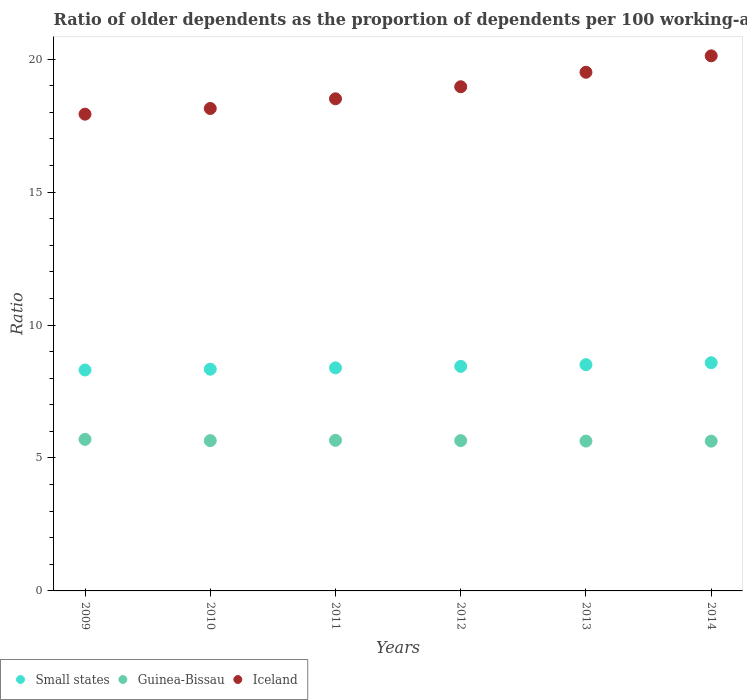How many different coloured dotlines are there?
Make the answer very short. 3. Is the number of dotlines equal to the number of legend labels?
Ensure brevity in your answer.  Yes. What is the age dependency ratio(old) in Guinea-Bissau in 2011?
Provide a short and direct response. 5.66. Across all years, what is the maximum age dependency ratio(old) in Small states?
Provide a short and direct response. 8.58. Across all years, what is the minimum age dependency ratio(old) in Guinea-Bissau?
Your answer should be compact. 5.63. In which year was the age dependency ratio(old) in Small states maximum?
Offer a very short reply. 2014. In which year was the age dependency ratio(old) in Iceland minimum?
Your answer should be very brief. 2009. What is the total age dependency ratio(old) in Guinea-Bissau in the graph?
Ensure brevity in your answer.  33.94. What is the difference between the age dependency ratio(old) in Guinea-Bissau in 2011 and that in 2013?
Your answer should be very brief. 0.03. What is the difference between the age dependency ratio(old) in Iceland in 2011 and the age dependency ratio(old) in Guinea-Bissau in 2009?
Offer a very short reply. 12.81. What is the average age dependency ratio(old) in Small states per year?
Your response must be concise. 8.43. In the year 2013, what is the difference between the age dependency ratio(old) in Guinea-Bissau and age dependency ratio(old) in Iceland?
Offer a very short reply. -13.87. What is the ratio of the age dependency ratio(old) in Guinea-Bissau in 2009 to that in 2013?
Your answer should be compact. 1.01. What is the difference between the highest and the second highest age dependency ratio(old) in Iceland?
Offer a very short reply. 0.62. What is the difference between the highest and the lowest age dependency ratio(old) in Small states?
Provide a succinct answer. 0.27. In how many years, is the age dependency ratio(old) in Guinea-Bissau greater than the average age dependency ratio(old) in Guinea-Bissau taken over all years?
Offer a terse response. 2. Is the sum of the age dependency ratio(old) in Small states in 2011 and 2013 greater than the maximum age dependency ratio(old) in Iceland across all years?
Make the answer very short. No. Is the age dependency ratio(old) in Guinea-Bissau strictly greater than the age dependency ratio(old) in Iceland over the years?
Offer a terse response. No. How many dotlines are there?
Your response must be concise. 3. How many years are there in the graph?
Offer a very short reply. 6. What is the difference between two consecutive major ticks on the Y-axis?
Keep it short and to the point. 5. Are the values on the major ticks of Y-axis written in scientific E-notation?
Keep it short and to the point. No. Does the graph contain any zero values?
Your response must be concise. No. How many legend labels are there?
Your answer should be compact. 3. What is the title of the graph?
Ensure brevity in your answer.  Ratio of older dependents as the proportion of dependents per 100 working-age population. Does "Iceland" appear as one of the legend labels in the graph?
Provide a short and direct response. Yes. What is the label or title of the X-axis?
Give a very brief answer. Years. What is the label or title of the Y-axis?
Offer a very short reply. Ratio. What is the Ratio of Small states in 2009?
Keep it short and to the point. 8.31. What is the Ratio of Guinea-Bissau in 2009?
Offer a very short reply. 5.7. What is the Ratio in Iceland in 2009?
Provide a short and direct response. 17.93. What is the Ratio of Small states in 2010?
Provide a succinct answer. 8.34. What is the Ratio of Guinea-Bissau in 2010?
Offer a terse response. 5.65. What is the Ratio in Iceland in 2010?
Your answer should be very brief. 18.15. What is the Ratio in Small states in 2011?
Your answer should be very brief. 8.39. What is the Ratio of Guinea-Bissau in 2011?
Keep it short and to the point. 5.66. What is the Ratio of Iceland in 2011?
Your response must be concise. 18.51. What is the Ratio in Small states in 2012?
Make the answer very short. 8.45. What is the Ratio of Guinea-Bissau in 2012?
Ensure brevity in your answer.  5.65. What is the Ratio in Iceland in 2012?
Offer a terse response. 18.96. What is the Ratio of Small states in 2013?
Provide a succinct answer. 8.51. What is the Ratio in Guinea-Bissau in 2013?
Provide a succinct answer. 5.64. What is the Ratio of Iceland in 2013?
Ensure brevity in your answer.  19.51. What is the Ratio of Small states in 2014?
Provide a short and direct response. 8.58. What is the Ratio of Guinea-Bissau in 2014?
Provide a short and direct response. 5.63. What is the Ratio in Iceland in 2014?
Provide a short and direct response. 20.13. Across all years, what is the maximum Ratio in Small states?
Make the answer very short. 8.58. Across all years, what is the maximum Ratio in Guinea-Bissau?
Provide a succinct answer. 5.7. Across all years, what is the maximum Ratio of Iceland?
Make the answer very short. 20.13. Across all years, what is the minimum Ratio in Small states?
Make the answer very short. 8.31. Across all years, what is the minimum Ratio of Guinea-Bissau?
Give a very brief answer. 5.63. Across all years, what is the minimum Ratio of Iceland?
Keep it short and to the point. 17.93. What is the total Ratio of Small states in the graph?
Make the answer very short. 50.58. What is the total Ratio in Guinea-Bissau in the graph?
Offer a very short reply. 33.94. What is the total Ratio in Iceland in the graph?
Offer a very short reply. 113.19. What is the difference between the Ratio of Small states in 2009 and that in 2010?
Your response must be concise. -0.03. What is the difference between the Ratio in Guinea-Bissau in 2009 and that in 2010?
Make the answer very short. 0.05. What is the difference between the Ratio of Iceland in 2009 and that in 2010?
Your answer should be very brief. -0.21. What is the difference between the Ratio of Small states in 2009 and that in 2011?
Provide a short and direct response. -0.08. What is the difference between the Ratio in Guinea-Bissau in 2009 and that in 2011?
Your answer should be compact. 0.04. What is the difference between the Ratio in Iceland in 2009 and that in 2011?
Offer a terse response. -0.58. What is the difference between the Ratio of Small states in 2009 and that in 2012?
Your answer should be compact. -0.14. What is the difference between the Ratio of Guinea-Bissau in 2009 and that in 2012?
Provide a succinct answer. 0.05. What is the difference between the Ratio in Iceland in 2009 and that in 2012?
Keep it short and to the point. -1.03. What is the difference between the Ratio of Small states in 2009 and that in 2013?
Offer a very short reply. -0.2. What is the difference between the Ratio in Guinea-Bissau in 2009 and that in 2013?
Keep it short and to the point. 0.06. What is the difference between the Ratio of Iceland in 2009 and that in 2013?
Offer a terse response. -1.58. What is the difference between the Ratio of Small states in 2009 and that in 2014?
Provide a succinct answer. -0.27. What is the difference between the Ratio in Guinea-Bissau in 2009 and that in 2014?
Your answer should be compact. 0.07. What is the difference between the Ratio in Iceland in 2009 and that in 2014?
Ensure brevity in your answer.  -2.19. What is the difference between the Ratio of Small states in 2010 and that in 2011?
Give a very brief answer. -0.05. What is the difference between the Ratio of Guinea-Bissau in 2010 and that in 2011?
Provide a succinct answer. -0.01. What is the difference between the Ratio in Iceland in 2010 and that in 2011?
Provide a succinct answer. -0.36. What is the difference between the Ratio in Small states in 2010 and that in 2012?
Your response must be concise. -0.11. What is the difference between the Ratio of Guinea-Bissau in 2010 and that in 2012?
Keep it short and to the point. -0. What is the difference between the Ratio in Iceland in 2010 and that in 2012?
Give a very brief answer. -0.82. What is the difference between the Ratio of Small states in 2010 and that in 2013?
Ensure brevity in your answer.  -0.17. What is the difference between the Ratio of Guinea-Bissau in 2010 and that in 2013?
Offer a terse response. 0.02. What is the difference between the Ratio of Iceland in 2010 and that in 2013?
Your answer should be very brief. -1.36. What is the difference between the Ratio of Small states in 2010 and that in 2014?
Provide a succinct answer. -0.24. What is the difference between the Ratio in Guinea-Bissau in 2010 and that in 2014?
Offer a very short reply. 0.02. What is the difference between the Ratio of Iceland in 2010 and that in 2014?
Offer a very short reply. -1.98. What is the difference between the Ratio in Small states in 2011 and that in 2012?
Keep it short and to the point. -0.06. What is the difference between the Ratio of Guinea-Bissau in 2011 and that in 2012?
Your answer should be compact. 0.01. What is the difference between the Ratio of Iceland in 2011 and that in 2012?
Make the answer very short. -0.45. What is the difference between the Ratio of Small states in 2011 and that in 2013?
Offer a very short reply. -0.12. What is the difference between the Ratio in Guinea-Bissau in 2011 and that in 2013?
Keep it short and to the point. 0.03. What is the difference between the Ratio in Iceland in 2011 and that in 2013?
Give a very brief answer. -1. What is the difference between the Ratio in Small states in 2011 and that in 2014?
Ensure brevity in your answer.  -0.19. What is the difference between the Ratio of Guinea-Bissau in 2011 and that in 2014?
Make the answer very short. 0.03. What is the difference between the Ratio of Iceland in 2011 and that in 2014?
Make the answer very short. -1.62. What is the difference between the Ratio of Small states in 2012 and that in 2013?
Provide a succinct answer. -0.06. What is the difference between the Ratio in Guinea-Bissau in 2012 and that in 2013?
Your answer should be very brief. 0.02. What is the difference between the Ratio of Iceland in 2012 and that in 2013?
Keep it short and to the point. -0.55. What is the difference between the Ratio in Small states in 2012 and that in 2014?
Give a very brief answer. -0.14. What is the difference between the Ratio in Guinea-Bissau in 2012 and that in 2014?
Give a very brief answer. 0.02. What is the difference between the Ratio in Iceland in 2012 and that in 2014?
Make the answer very short. -1.16. What is the difference between the Ratio of Small states in 2013 and that in 2014?
Give a very brief answer. -0.07. What is the difference between the Ratio of Guinea-Bissau in 2013 and that in 2014?
Your answer should be very brief. 0. What is the difference between the Ratio in Iceland in 2013 and that in 2014?
Give a very brief answer. -0.62. What is the difference between the Ratio in Small states in 2009 and the Ratio in Guinea-Bissau in 2010?
Your answer should be very brief. 2.66. What is the difference between the Ratio of Small states in 2009 and the Ratio of Iceland in 2010?
Ensure brevity in your answer.  -9.84. What is the difference between the Ratio in Guinea-Bissau in 2009 and the Ratio in Iceland in 2010?
Provide a succinct answer. -12.45. What is the difference between the Ratio of Small states in 2009 and the Ratio of Guinea-Bissau in 2011?
Give a very brief answer. 2.64. What is the difference between the Ratio in Small states in 2009 and the Ratio in Iceland in 2011?
Your answer should be compact. -10.2. What is the difference between the Ratio of Guinea-Bissau in 2009 and the Ratio of Iceland in 2011?
Provide a succinct answer. -12.81. What is the difference between the Ratio in Small states in 2009 and the Ratio in Guinea-Bissau in 2012?
Ensure brevity in your answer.  2.66. What is the difference between the Ratio in Small states in 2009 and the Ratio in Iceland in 2012?
Offer a terse response. -10.65. What is the difference between the Ratio of Guinea-Bissau in 2009 and the Ratio of Iceland in 2012?
Keep it short and to the point. -13.26. What is the difference between the Ratio in Small states in 2009 and the Ratio in Guinea-Bissau in 2013?
Make the answer very short. 2.67. What is the difference between the Ratio in Small states in 2009 and the Ratio in Iceland in 2013?
Make the answer very short. -11.2. What is the difference between the Ratio in Guinea-Bissau in 2009 and the Ratio in Iceland in 2013?
Offer a terse response. -13.81. What is the difference between the Ratio in Small states in 2009 and the Ratio in Guinea-Bissau in 2014?
Provide a succinct answer. 2.68. What is the difference between the Ratio of Small states in 2009 and the Ratio of Iceland in 2014?
Provide a succinct answer. -11.82. What is the difference between the Ratio in Guinea-Bissau in 2009 and the Ratio in Iceland in 2014?
Keep it short and to the point. -14.43. What is the difference between the Ratio in Small states in 2010 and the Ratio in Guinea-Bissau in 2011?
Your response must be concise. 2.68. What is the difference between the Ratio of Small states in 2010 and the Ratio of Iceland in 2011?
Provide a short and direct response. -10.17. What is the difference between the Ratio in Guinea-Bissau in 2010 and the Ratio in Iceland in 2011?
Offer a very short reply. -12.86. What is the difference between the Ratio of Small states in 2010 and the Ratio of Guinea-Bissau in 2012?
Give a very brief answer. 2.69. What is the difference between the Ratio in Small states in 2010 and the Ratio in Iceland in 2012?
Your answer should be compact. -10.62. What is the difference between the Ratio of Guinea-Bissau in 2010 and the Ratio of Iceland in 2012?
Offer a very short reply. -13.31. What is the difference between the Ratio in Small states in 2010 and the Ratio in Guinea-Bissau in 2013?
Keep it short and to the point. 2.7. What is the difference between the Ratio of Small states in 2010 and the Ratio of Iceland in 2013?
Keep it short and to the point. -11.17. What is the difference between the Ratio of Guinea-Bissau in 2010 and the Ratio of Iceland in 2013?
Offer a very short reply. -13.86. What is the difference between the Ratio in Small states in 2010 and the Ratio in Guinea-Bissau in 2014?
Offer a very short reply. 2.71. What is the difference between the Ratio of Small states in 2010 and the Ratio of Iceland in 2014?
Offer a very short reply. -11.79. What is the difference between the Ratio of Guinea-Bissau in 2010 and the Ratio of Iceland in 2014?
Offer a very short reply. -14.47. What is the difference between the Ratio in Small states in 2011 and the Ratio in Guinea-Bissau in 2012?
Ensure brevity in your answer.  2.74. What is the difference between the Ratio of Small states in 2011 and the Ratio of Iceland in 2012?
Offer a very short reply. -10.57. What is the difference between the Ratio in Guinea-Bissau in 2011 and the Ratio in Iceland in 2012?
Ensure brevity in your answer.  -13.3. What is the difference between the Ratio in Small states in 2011 and the Ratio in Guinea-Bissau in 2013?
Keep it short and to the point. 2.75. What is the difference between the Ratio in Small states in 2011 and the Ratio in Iceland in 2013?
Give a very brief answer. -11.12. What is the difference between the Ratio of Guinea-Bissau in 2011 and the Ratio of Iceland in 2013?
Provide a short and direct response. -13.84. What is the difference between the Ratio in Small states in 2011 and the Ratio in Guinea-Bissau in 2014?
Your answer should be very brief. 2.76. What is the difference between the Ratio in Small states in 2011 and the Ratio in Iceland in 2014?
Provide a short and direct response. -11.74. What is the difference between the Ratio of Guinea-Bissau in 2011 and the Ratio of Iceland in 2014?
Ensure brevity in your answer.  -14.46. What is the difference between the Ratio in Small states in 2012 and the Ratio in Guinea-Bissau in 2013?
Ensure brevity in your answer.  2.81. What is the difference between the Ratio in Small states in 2012 and the Ratio in Iceland in 2013?
Give a very brief answer. -11.06. What is the difference between the Ratio of Guinea-Bissau in 2012 and the Ratio of Iceland in 2013?
Your response must be concise. -13.86. What is the difference between the Ratio in Small states in 2012 and the Ratio in Guinea-Bissau in 2014?
Ensure brevity in your answer.  2.81. What is the difference between the Ratio in Small states in 2012 and the Ratio in Iceland in 2014?
Your response must be concise. -11.68. What is the difference between the Ratio in Guinea-Bissau in 2012 and the Ratio in Iceland in 2014?
Offer a very short reply. -14.47. What is the difference between the Ratio of Small states in 2013 and the Ratio of Guinea-Bissau in 2014?
Ensure brevity in your answer.  2.88. What is the difference between the Ratio in Small states in 2013 and the Ratio in Iceland in 2014?
Offer a terse response. -11.62. What is the difference between the Ratio in Guinea-Bissau in 2013 and the Ratio in Iceland in 2014?
Provide a succinct answer. -14.49. What is the average Ratio of Small states per year?
Give a very brief answer. 8.43. What is the average Ratio of Guinea-Bissau per year?
Ensure brevity in your answer.  5.66. What is the average Ratio in Iceland per year?
Your answer should be compact. 18.86. In the year 2009, what is the difference between the Ratio in Small states and Ratio in Guinea-Bissau?
Provide a succinct answer. 2.61. In the year 2009, what is the difference between the Ratio in Small states and Ratio in Iceland?
Make the answer very short. -9.62. In the year 2009, what is the difference between the Ratio in Guinea-Bissau and Ratio in Iceland?
Offer a terse response. -12.23. In the year 2010, what is the difference between the Ratio in Small states and Ratio in Guinea-Bissau?
Give a very brief answer. 2.69. In the year 2010, what is the difference between the Ratio of Small states and Ratio of Iceland?
Make the answer very short. -9.81. In the year 2010, what is the difference between the Ratio in Guinea-Bissau and Ratio in Iceland?
Provide a succinct answer. -12.49. In the year 2011, what is the difference between the Ratio of Small states and Ratio of Guinea-Bissau?
Keep it short and to the point. 2.72. In the year 2011, what is the difference between the Ratio in Small states and Ratio in Iceland?
Keep it short and to the point. -10.12. In the year 2011, what is the difference between the Ratio in Guinea-Bissau and Ratio in Iceland?
Make the answer very short. -12.85. In the year 2012, what is the difference between the Ratio in Small states and Ratio in Guinea-Bissau?
Offer a terse response. 2.79. In the year 2012, what is the difference between the Ratio of Small states and Ratio of Iceland?
Give a very brief answer. -10.52. In the year 2012, what is the difference between the Ratio of Guinea-Bissau and Ratio of Iceland?
Provide a succinct answer. -13.31. In the year 2013, what is the difference between the Ratio of Small states and Ratio of Guinea-Bissau?
Keep it short and to the point. 2.87. In the year 2013, what is the difference between the Ratio of Small states and Ratio of Iceland?
Your answer should be very brief. -11. In the year 2013, what is the difference between the Ratio in Guinea-Bissau and Ratio in Iceland?
Provide a short and direct response. -13.87. In the year 2014, what is the difference between the Ratio in Small states and Ratio in Guinea-Bissau?
Offer a terse response. 2.95. In the year 2014, what is the difference between the Ratio of Small states and Ratio of Iceland?
Offer a very short reply. -11.54. In the year 2014, what is the difference between the Ratio in Guinea-Bissau and Ratio in Iceland?
Give a very brief answer. -14.49. What is the ratio of the Ratio of Guinea-Bissau in 2009 to that in 2010?
Your answer should be very brief. 1.01. What is the ratio of the Ratio in Iceland in 2009 to that in 2010?
Offer a terse response. 0.99. What is the ratio of the Ratio in Iceland in 2009 to that in 2011?
Your answer should be compact. 0.97. What is the ratio of the Ratio of Small states in 2009 to that in 2012?
Offer a terse response. 0.98. What is the ratio of the Ratio in Guinea-Bissau in 2009 to that in 2012?
Your answer should be compact. 1.01. What is the ratio of the Ratio in Iceland in 2009 to that in 2012?
Your answer should be very brief. 0.95. What is the ratio of the Ratio in Small states in 2009 to that in 2013?
Offer a very short reply. 0.98. What is the ratio of the Ratio in Guinea-Bissau in 2009 to that in 2013?
Offer a terse response. 1.01. What is the ratio of the Ratio of Iceland in 2009 to that in 2013?
Your answer should be compact. 0.92. What is the ratio of the Ratio in Small states in 2009 to that in 2014?
Ensure brevity in your answer.  0.97. What is the ratio of the Ratio of Guinea-Bissau in 2009 to that in 2014?
Give a very brief answer. 1.01. What is the ratio of the Ratio of Iceland in 2009 to that in 2014?
Ensure brevity in your answer.  0.89. What is the ratio of the Ratio in Guinea-Bissau in 2010 to that in 2011?
Your response must be concise. 1. What is the ratio of the Ratio in Iceland in 2010 to that in 2011?
Provide a short and direct response. 0.98. What is the ratio of the Ratio in Small states in 2010 to that in 2012?
Offer a terse response. 0.99. What is the ratio of the Ratio in Iceland in 2010 to that in 2012?
Your response must be concise. 0.96. What is the ratio of the Ratio in Guinea-Bissau in 2010 to that in 2013?
Provide a short and direct response. 1. What is the ratio of the Ratio in Iceland in 2010 to that in 2013?
Your answer should be very brief. 0.93. What is the ratio of the Ratio of Small states in 2010 to that in 2014?
Provide a short and direct response. 0.97. What is the ratio of the Ratio of Iceland in 2010 to that in 2014?
Your response must be concise. 0.9. What is the ratio of the Ratio of Guinea-Bissau in 2011 to that in 2012?
Offer a terse response. 1. What is the ratio of the Ratio of Iceland in 2011 to that in 2012?
Your response must be concise. 0.98. What is the ratio of the Ratio in Small states in 2011 to that in 2013?
Your answer should be compact. 0.99. What is the ratio of the Ratio in Iceland in 2011 to that in 2013?
Provide a succinct answer. 0.95. What is the ratio of the Ratio of Small states in 2011 to that in 2014?
Your answer should be compact. 0.98. What is the ratio of the Ratio of Iceland in 2011 to that in 2014?
Give a very brief answer. 0.92. What is the ratio of the Ratio of Small states in 2012 to that in 2013?
Give a very brief answer. 0.99. What is the ratio of the Ratio of Guinea-Bissau in 2012 to that in 2013?
Ensure brevity in your answer.  1. What is the ratio of the Ratio of Iceland in 2012 to that in 2013?
Ensure brevity in your answer.  0.97. What is the ratio of the Ratio of Small states in 2012 to that in 2014?
Offer a terse response. 0.98. What is the ratio of the Ratio of Guinea-Bissau in 2012 to that in 2014?
Your answer should be compact. 1. What is the ratio of the Ratio of Iceland in 2012 to that in 2014?
Your response must be concise. 0.94. What is the ratio of the Ratio in Guinea-Bissau in 2013 to that in 2014?
Keep it short and to the point. 1. What is the ratio of the Ratio in Iceland in 2013 to that in 2014?
Give a very brief answer. 0.97. What is the difference between the highest and the second highest Ratio in Small states?
Offer a terse response. 0.07. What is the difference between the highest and the second highest Ratio in Guinea-Bissau?
Give a very brief answer. 0.04. What is the difference between the highest and the second highest Ratio of Iceland?
Give a very brief answer. 0.62. What is the difference between the highest and the lowest Ratio in Small states?
Keep it short and to the point. 0.27. What is the difference between the highest and the lowest Ratio in Guinea-Bissau?
Make the answer very short. 0.07. What is the difference between the highest and the lowest Ratio of Iceland?
Offer a terse response. 2.19. 